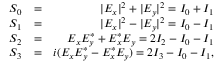<formula> <loc_0><loc_0><loc_500><loc_500>\begin{array} { r l r } { S _ { 0 } } & { = } & { | E _ { x } | ^ { 2 } + | E _ { y } | ^ { 2 } = I _ { 0 } + I _ { 1 } } \\ { S _ { 1 } } & { = } & { | E _ { x } | ^ { 2 } - | E _ { y } | ^ { 2 } = I _ { 0 } - I _ { 1 } } \\ { S _ { 2 } } & { = } & { E _ { x } E _ { y } ^ { * } + E _ { x } ^ { * } E _ { y } = 2 I _ { 2 } - I _ { 0 } - I _ { 1 } } \\ { S _ { 3 } } & { = } & { i ( E _ { x } E _ { y } ^ { * } - E _ { x } ^ { * } E _ { y } ) = 2 I _ { 3 } - I _ { 0 } - I _ { 1 } , } \end{array}</formula> 